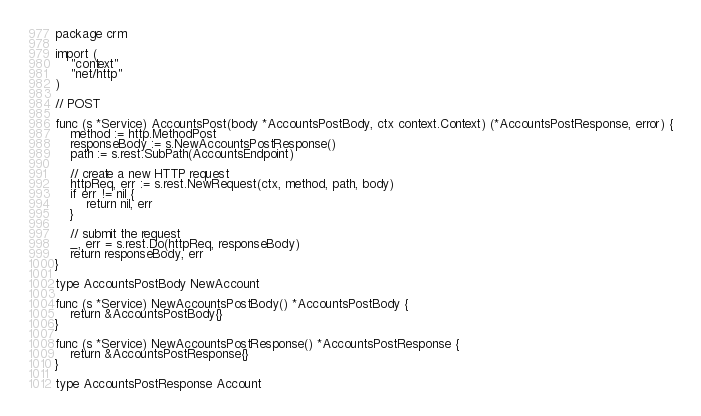<code> <loc_0><loc_0><loc_500><loc_500><_Go_>package crm

import (
	"context"
	"net/http"
)

// POST

func (s *Service) AccountsPost(body *AccountsPostBody, ctx context.Context) (*AccountsPostResponse, error) {
	method := http.MethodPost
	responseBody := s.NewAccountsPostResponse()
	path := s.rest.SubPath(AccountsEndpoint)

	// create a new HTTP request
	httpReq, err := s.rest.NewRequest(ctx, method, path, body)
	if err != nil {
		return nil, err
	}

	// submit the request
	_, err = s.rest.Do(httpReq, responseBody)
	return responseBody, err
}

type AccountsPostBody NewAccount

func (s *Service) NewAccountsPostBody() *AccountsPostBody {
	return &AccountsPostBody{}
}

func (s *Service) NewAccountsPostResponse() *AccountsPostResponse {
	return &AccountsPostResponse{}
}

type AccountsPostResponse Account
</code> 